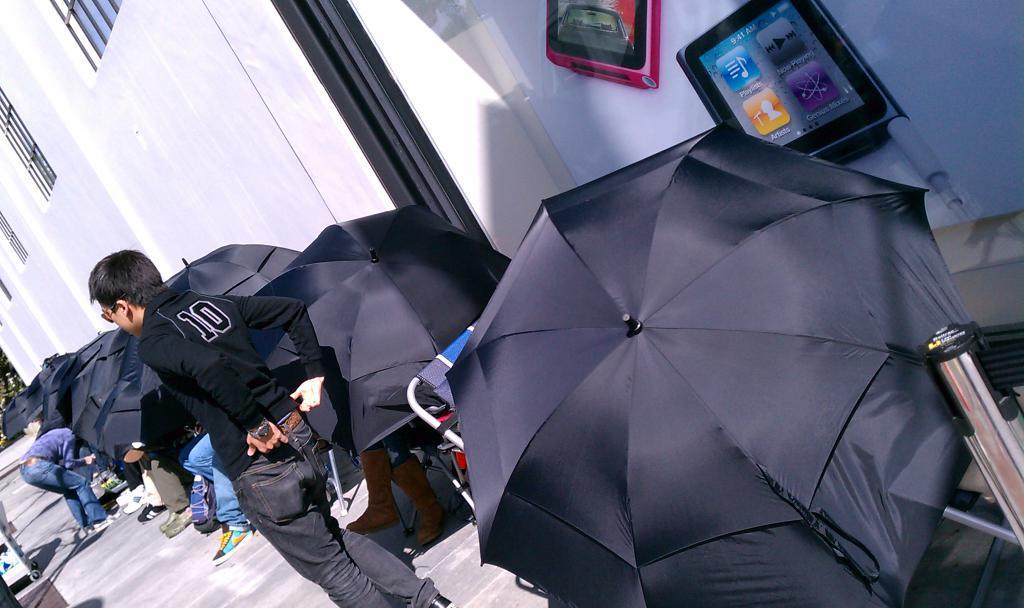Can you describe this image briefly? In this picture in the middle, we can see a man wearing a black color shirt is standing on the land. On the right side, we can see an umbrella, metal rod and few electronic instruments. On the left side, we can see a man and few umbrellas, trees. On the left corner, we can also see a vehicle. In the background there is a building, window, metal grills and white color wall. 